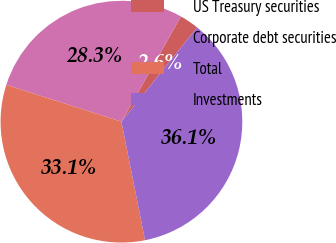Convert chart. <chart><loc_0><loc_0><loc_500><loc_500><pie_chart><fcel>US Treasury securities<fcel>Corporate debt securities<fcel>Total<fcel>Investments<nl><fcel>2.58%<fcel>28.26%<fcel>33.05%<fcel>36.1%<nl></chart> 